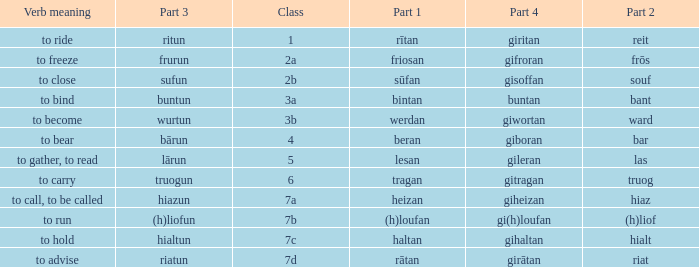What is the part 4 when part 1 is "lesan"? Gileran. 